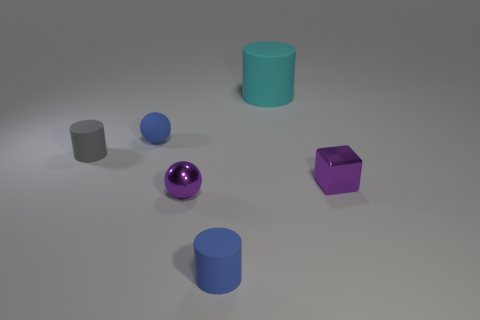Is the number of big things less than the number of rubber cylinders?
Provide a succinct answer. Yes. Is there anything else that has the same size as the cyan cylinder?
Keep it short and to the point. No. Does the small shiny ball have the same color as the shiny block?
Ensure brevity in your answer.  Yes. Is the number of tiny purple rubber cylinders greater than the number of small purple things?
Keep it short and to the point. No. What number of other things are the same color as the big rubber cylinder?
Your response must be concise. 0. How many rubber cylinders are behind the purple thing that is to the right of the purple sphere?
Give a very brief answer. 2. There is a small rubber sphere; are there any matte things to the right of it?
Ensure brevity in your answer.  Yes. There is a tiny blue rubber thing that is behind the matte object in front of the gray matte object; what is its shape?
Your response must be concise. Sphere. Are there fewer gray rubber objects on the right side of the small gray matte cylinder than small blue matte objects in front of the small purple shiny sphere?
Your answer should be very brief. Yes. What color is the other big thing that is the same shape as the gray matte object?
Provide a short and direct response. Cyan. 